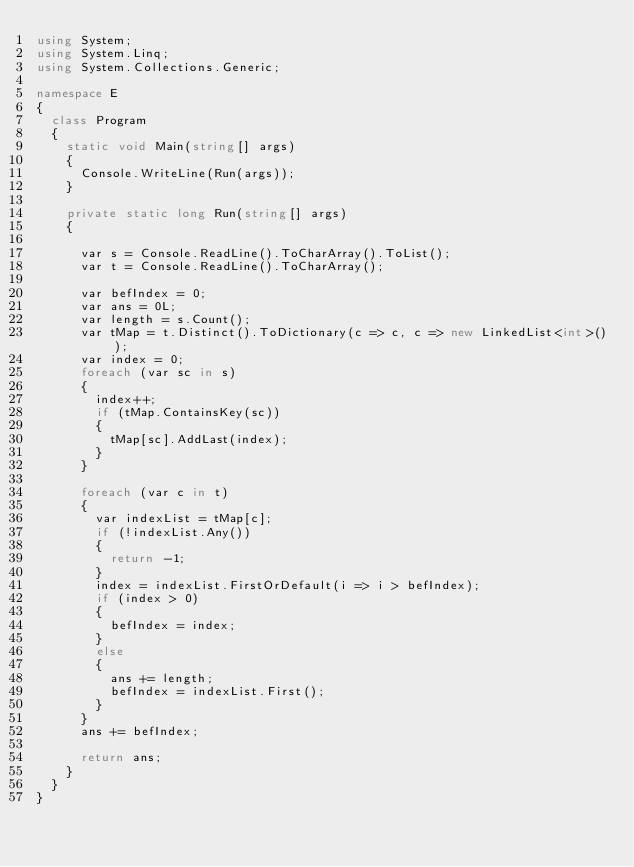Convert code to text. <code><loc_0><loc_0><loc_500><loc_500><_C#_>using System;
using System.Linq;
using System.Collections.Generic;

namespace E
{
  class Program
  {
    static void Main(string[] args)
    {
      Console.WriteLine(Run(args));
    }

    private static long Run(string[] args)
    {

      var s = Console.ReadLine().ToCharArray().ToList();
      var t = Console.ReadLine().ToCharArray();

      var befIndex = 0;
      var ans = 0L;
      var length = s.Count();
      var tMap = t.Distinct().ToDictionary(c => c, c => new LinkedList<int>());
      var index = 0;
      foreach (var sc in s)
      {
        index++;
        if (tMap.ContainsKey(sc))
        {
          tMap[sc].AddLast(index);
        }
      }

      foreach (var c in t)
      {
        var indexList = tMap[c];
        if (!indexList.Any())
        {
          return -1;
        }
        index = indexList.FirstOrDefault(i => i > befIndex);
        if (index > 0)
        {
          befIndex = index;
        }
        else
        {
          ans += length;
          befIndex = indexList.First();
        }
      }
      ans += befIndex;

      return ans;
    }
  }
}
</code> 